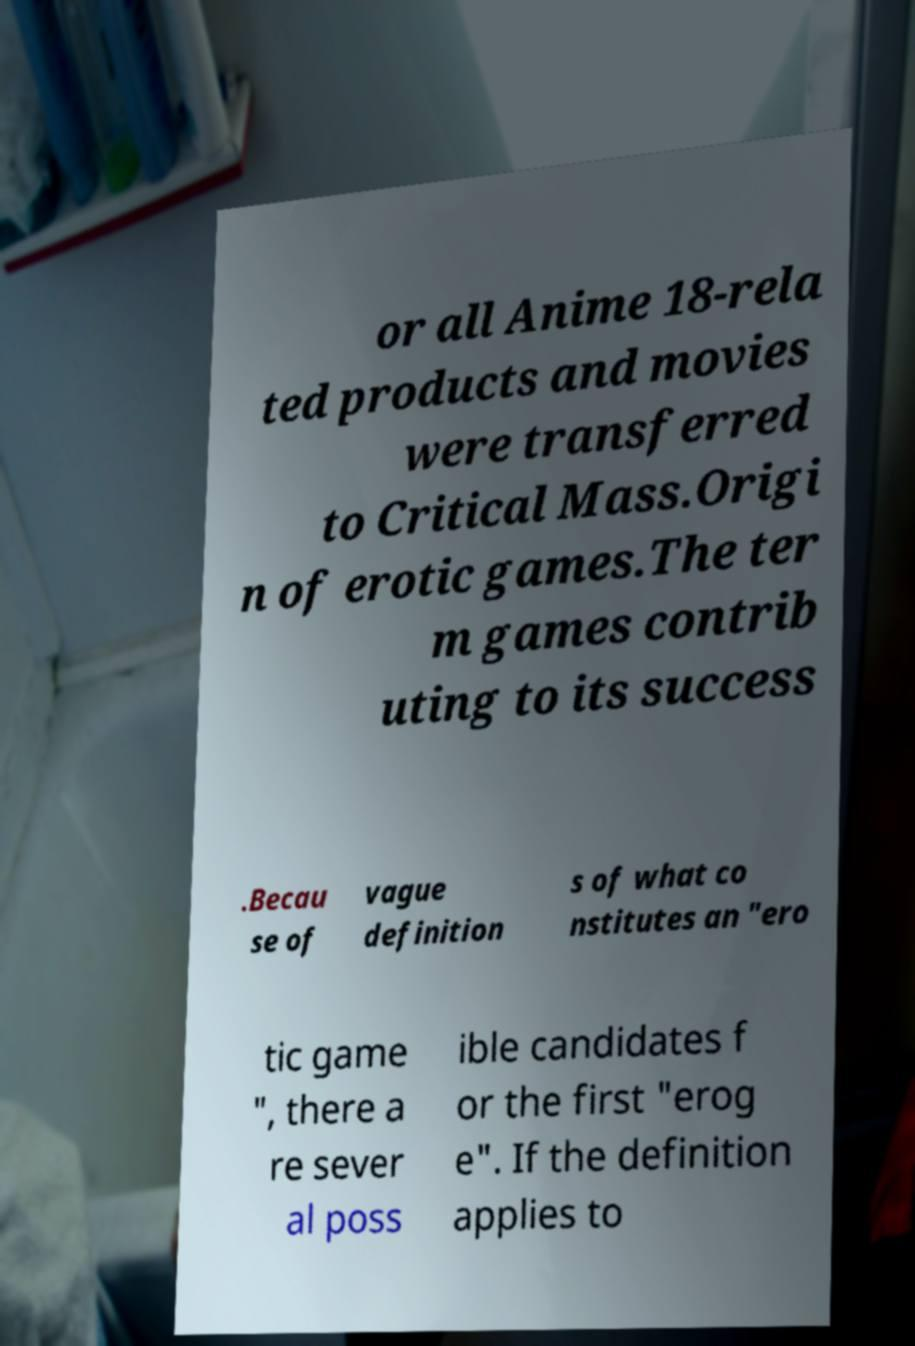Can you read and provide the text displayed in the image?This photo seems to have some interesting text. Can you extract and type it out for me? or all Anime 18-rela ted products and movies were transferred to Critical Mass.Origi n of erotic games.The ter m games contrib uting to its success .Becau se of vague definition s of what co nstitutes an "ero tic game ", there a re sever al poss ible candidates f or the first "erog e". If the definition applies to 